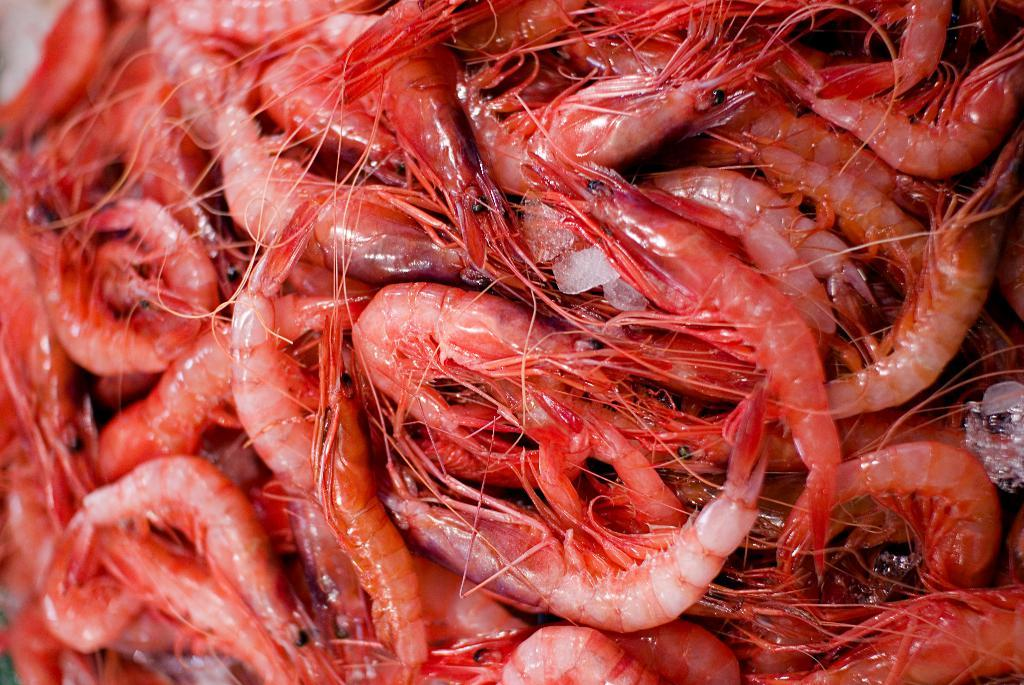What type of seafood is present in the image? There are many prawns in the image. Can you describe the quantity of prawns in the image? The image contains a large number of prawns. What might someone do with the prawns in the image? Someone might cook or prepare the prawns for consumption. What type of umbrella is being used to protect the prawns from the rain in the image? There is no umbrella present in the image, as it features prawns and not any umbrellas or rain. 